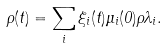Convert formula to latex. <formula><loc_0><loc_0><loc_500><loc_500>\rho ( t ) = \sum _ { i } \xi _ { i } ( t ) \mu _ { i } ( 0 ) \rho { \lambda _ { i } } .</formula> 